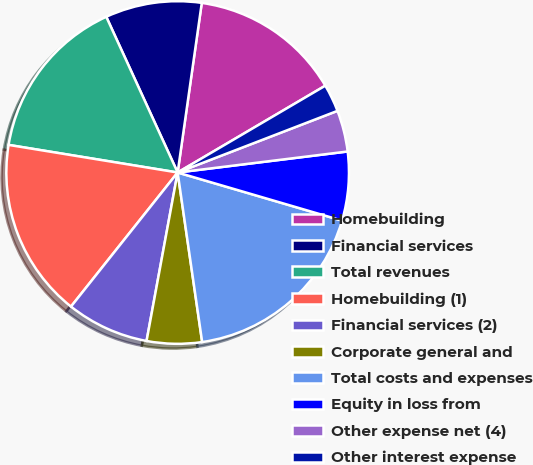Convert chart. <chart><loc_0><loc_0><loc_500><loc_500><pie_chart><fcel>Homebuilding<fcel>Financial services<fcel>Total revenues<fcel>Homebuilding (1)<fcel>Financial services (2)<fcel>Corporate general and<fcel>Total costs and expenses<fcel>Equity in loss from<fcel>Other expense net (4)<fcel>Other interest expense<nl><fcel>14.29%<fcel>9.09%<fcel>15.58%<fcel>16.88%<fcel>7.79%<fcel>5.19%<fcel>18.18%<fcel>6.49%<fcel>3.9%<fcel>2.6%<nl></chart> 